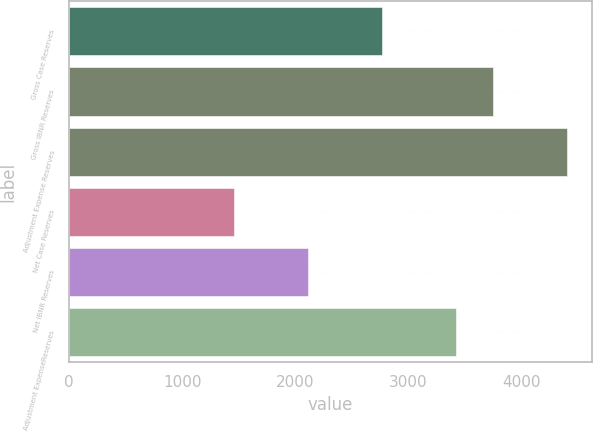<chart> <loc_0><loc_0><loc_500><loc_500><bar_chart><fcel>Gross Case Reserves<fcel>Gross IBNR Reserves<fcel>Adjustment Expense Reserves<fcel>Net Case Reserves<fcel>Net IBNR Reserves<fcel>Adjustment ExpenseReserves<nl><fcel>2763.5<fcel>3746<fcel>4401<fcel>1453.5<fcel>2108.5<fcel>3418.5<nl></chart> 